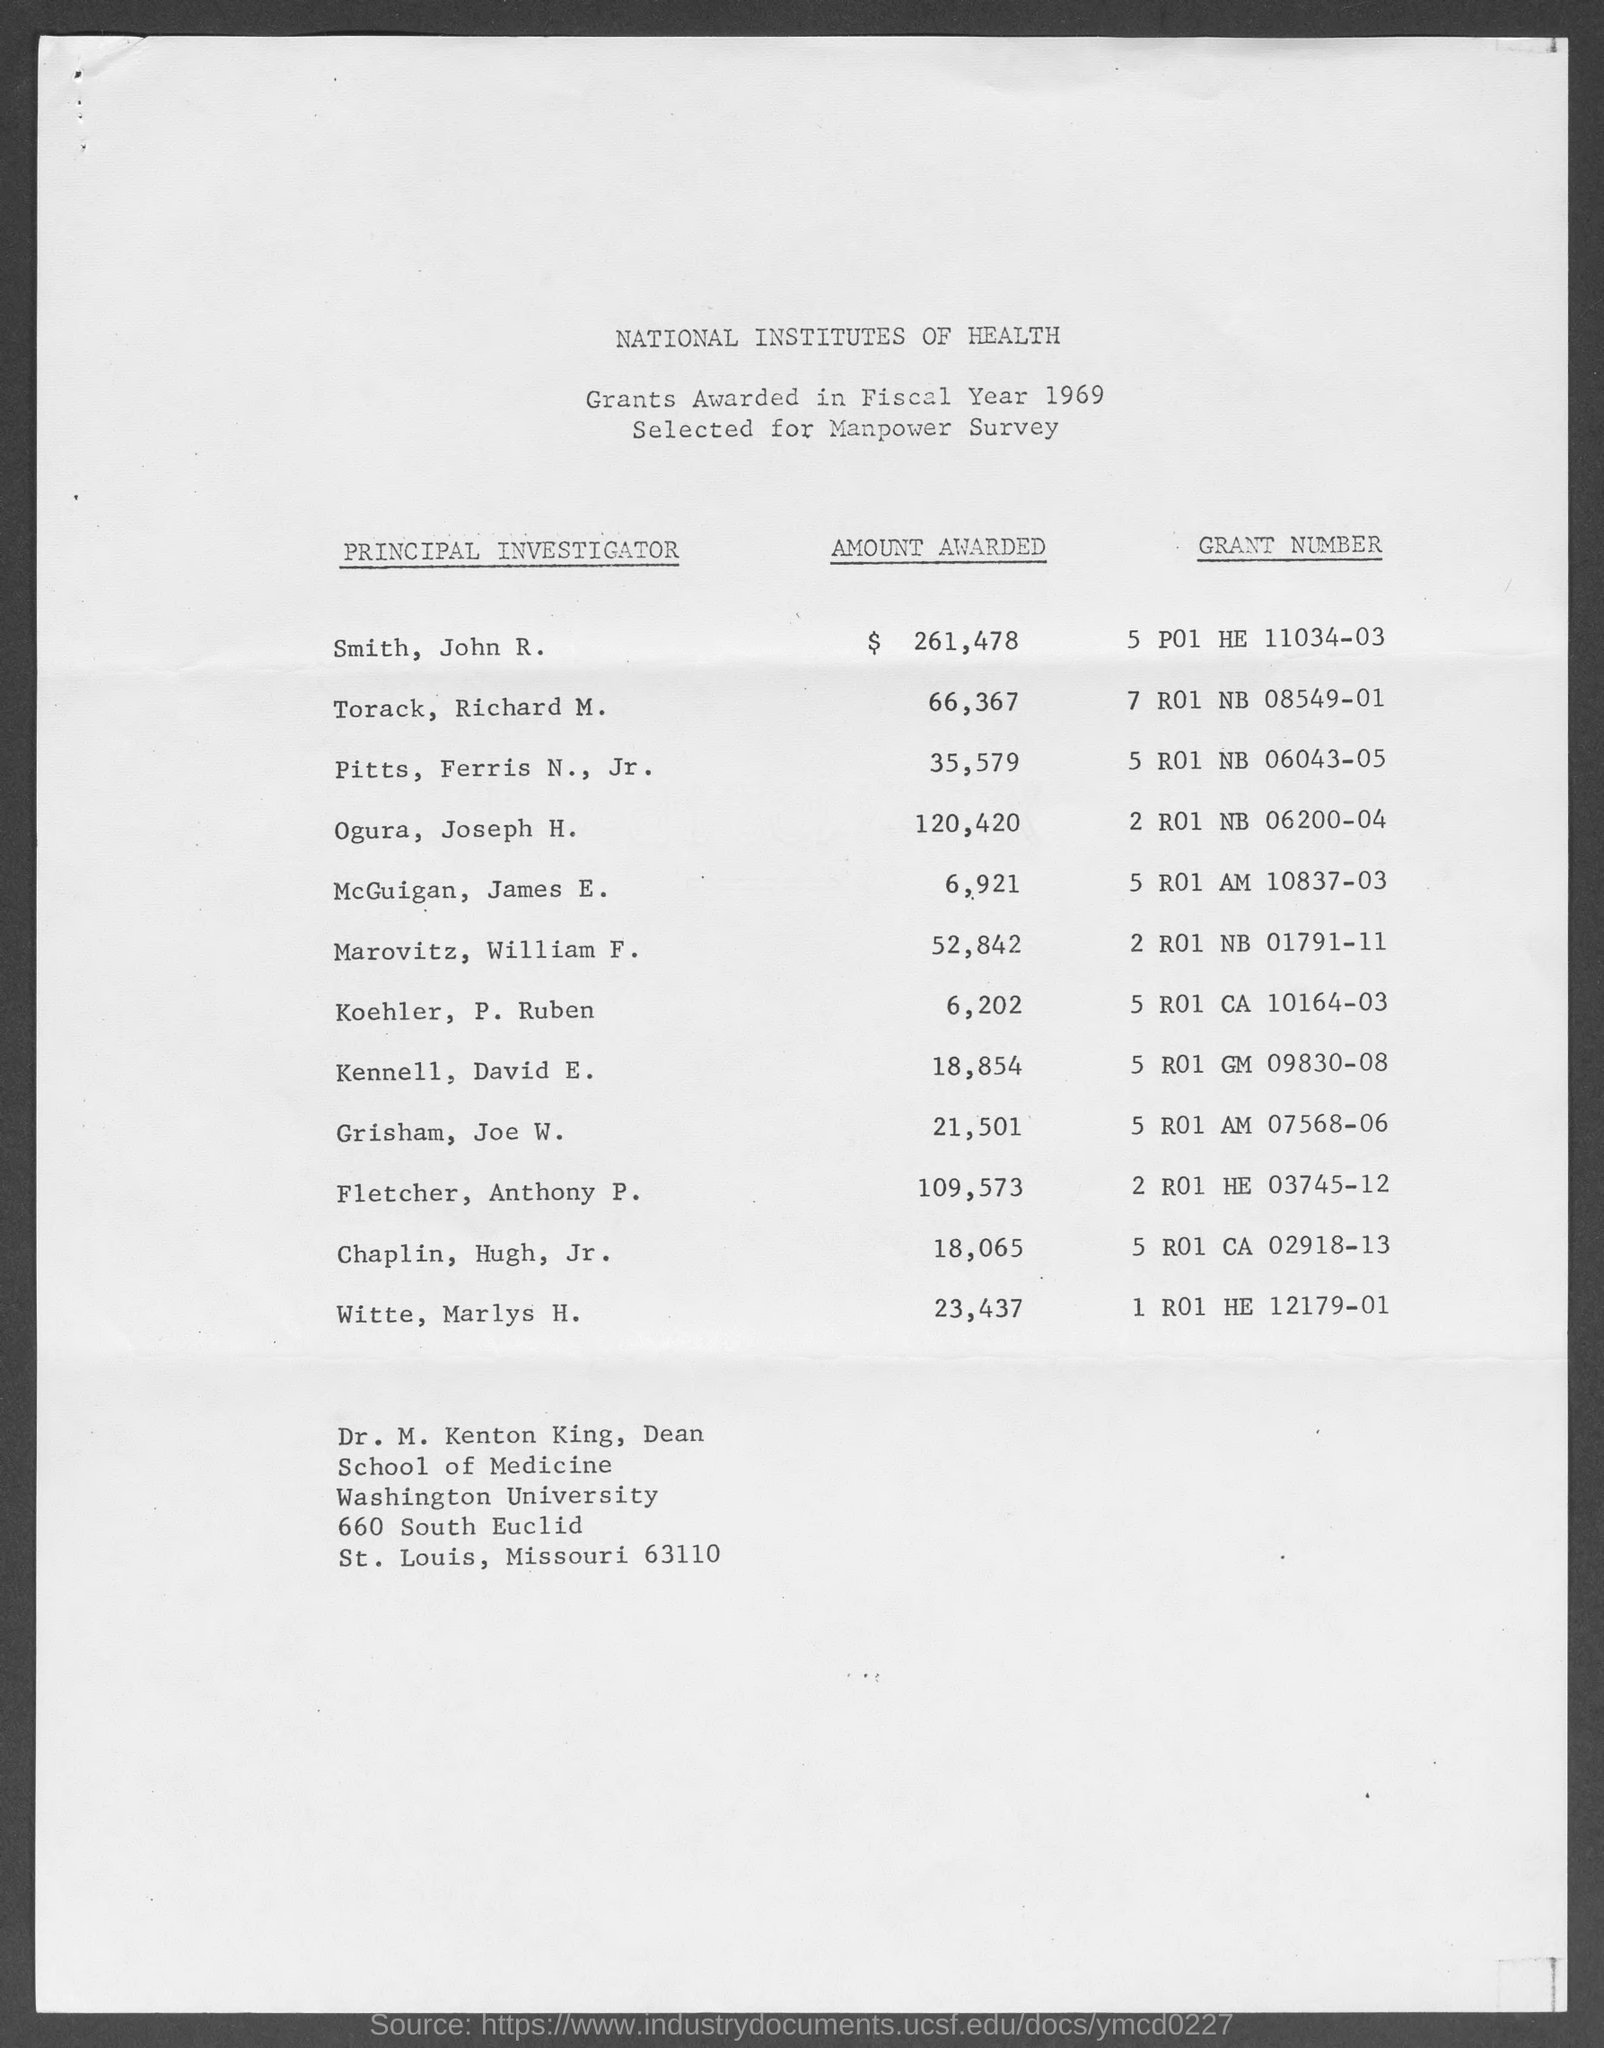Mention a couple of crucial points in this snapshot. Dr. M. Kenton King is the Dean of the School of Medicine at Washington University. The grant number "5 R01 NB 06043-05" is related to Pitts, Ferris N., Jr. The grant number "2 R01 NB 06200-04" is related to Joseph H. Ogura. John R. Smith was awarded a sum of $261,478. In the fiscal year of 1969, grants were awarded. 